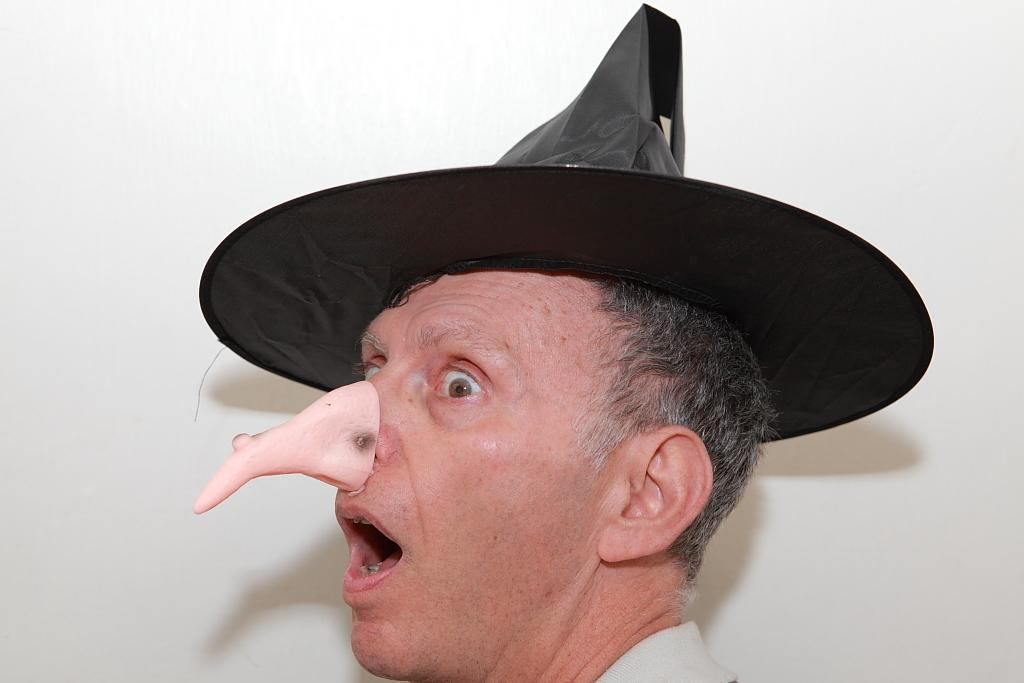What is the main subject in the foreground of the image? There is a man in the foreground of the image. What is the man doing with his mouth? The man has an open mouth. What accessory is the man wearing? The man is wearing a hat. What is unique about the man's nose? The man has a depicted sharp nose attached to his nose. What color is the background of the image? The background of the image is white. What type of food is the man eating in the image? There is no food present in the image; the man has an open mouth but is not shown eating anything. What sound can be heard coming from the man's mouth in the image? There is no sound present in the image; it is a still picture and does not convey any auditory information. 